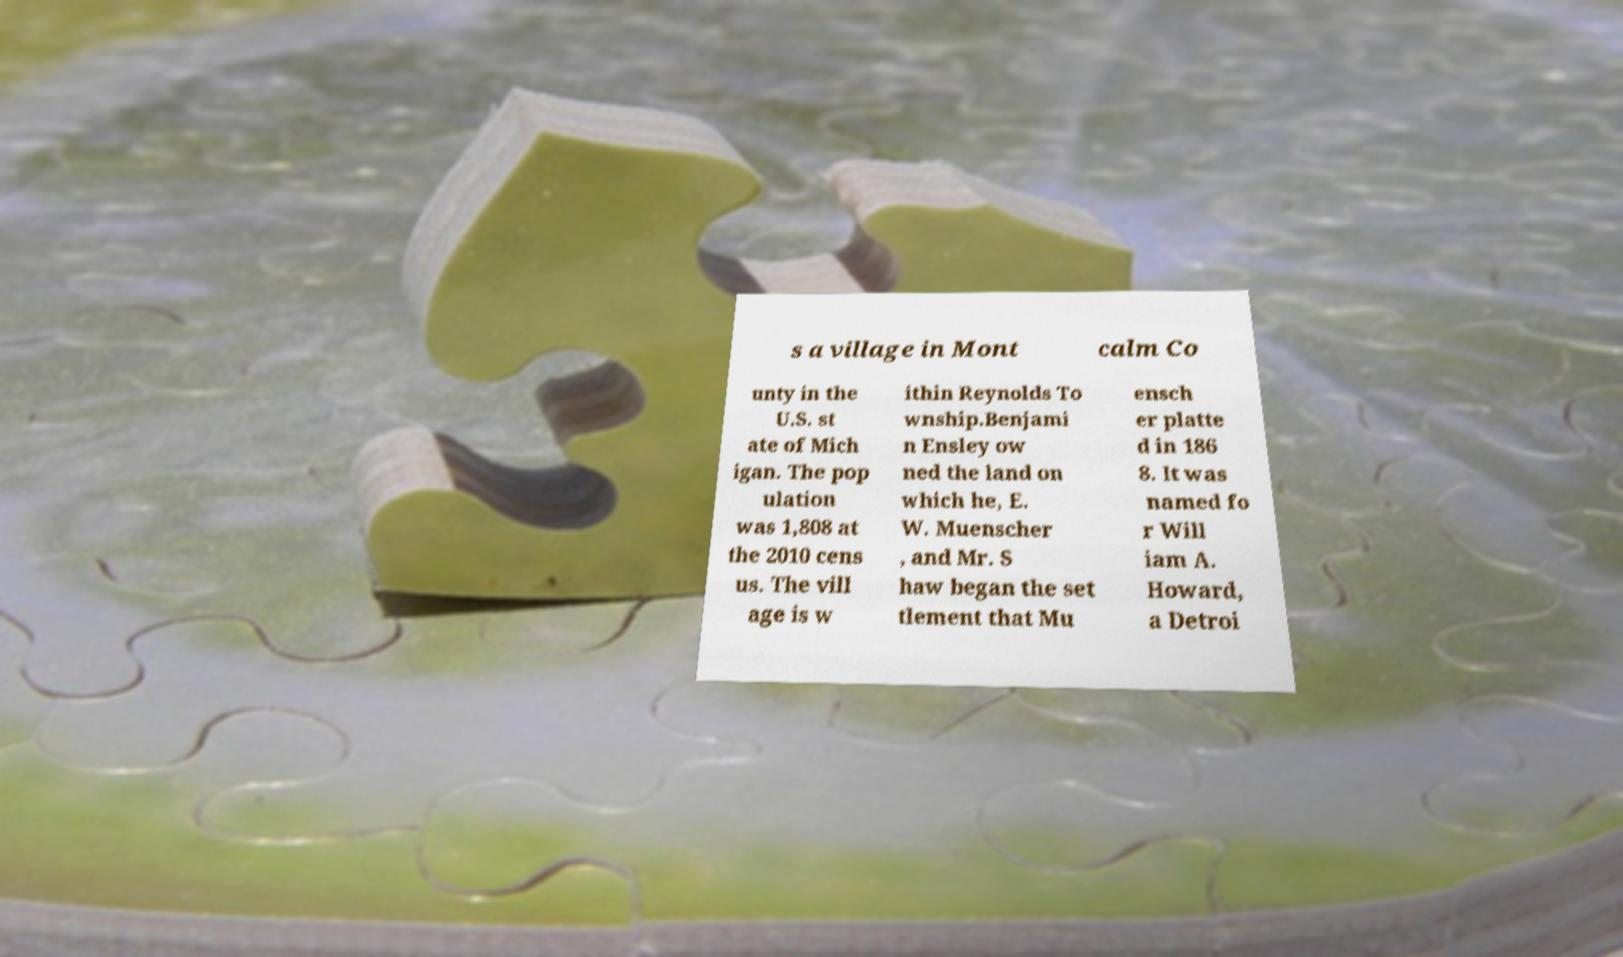Please read and relay the text visible in this image. What does it say? s a village in Mont calm Co unty in the U.S. st ate of Mich igan. The pop ulation was 1,808 at the 2010 cens us. The vill age is w ithin Reynolds To wnship.Benjami n Ensley ow ned the land on which he, E. W. Muenscher , and Mr. S haw began the set tlement that Mu ensch er platte d in 186 8. It was named fo r Will iam A. Howard, a Detroi 